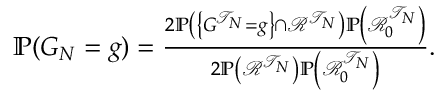Convert formula to latex. <formula><loc_0><loc_0><loc_500><loc_500>\begin{array} { r } { \mathbb { P } ( G _ { N } = g ) = \frac { 2 \mathbb { P } \left ( \left \{ G ^ { \mathcal { T } _ { N } } = g \right \} \cap \mathcal { R } ^ { \mathcal { T } _ { N } } \right ) \mathbb { P } \left ( \mathcal { R } _ { 0 } ^ { \mathcal { T } _ { N } } \right ) } { 2 \mathbb { P } \left ( \mathcal { R } ^ { \mathcal { T } _ { N } } \right ) \mathbb { P } \left ( \mathcal { R } _ { 0 } ^ { \mathcal { T } _ { N } } \right ) } . } \end{array}</formula> 